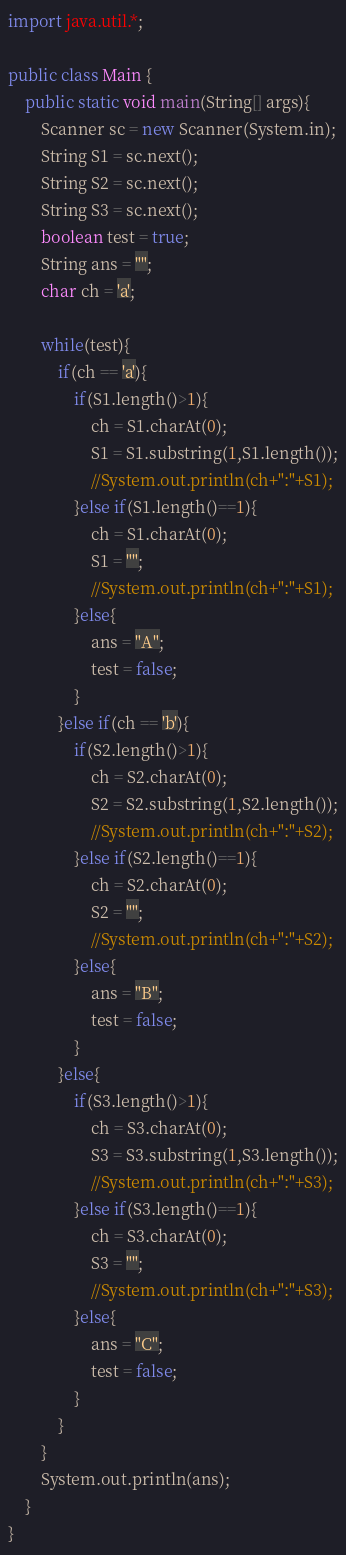<code> <loc_0><loc_0><loc_500><loc_500><_Java_>import java.util.*;

public class Main {
    public static void main(String[] args){
        Scanner sc = new Scanner(System.in);
        String S1 = sc.next();
        String S2 = sc.next();
        String S3 = sc.next();
        boolean test = true;
        String ans = "";
        char ch = 'a';
        
        while(test){
            if(ch == 'a'){
                if(S1.length()>1){
                    ch = S1.charAt(0);
                    S1 = S1.substring(1,S1.length());
                    //System.out.println(ch+":"+S1);
                }else if(S1.length()==1){
                    ch = S1.charAt(0);
                    S1 = "";
                    //System.out.println(ch+":"+S1);
                }else{
                    ans = "A";
                    test = false;
                }
            }else if(ch == 'b'){
                if(S2.length()>1){
                    ch = S2.charAt(0);
                    S2 = S2.substring(1,S2.length());
                    //System.out.println(ch+":"+S2);
                }else if(S2.length()==1){
                    ch = S2.charAt(0);
                    S2 = "";
                    //System.out.println(ch+":"+S2);
                }else{
                    ans = "B";
                    test = false;
                }
            }else{
                if(S3.length()>1){
                    ch = S3.charAt(0);
                    S3 = S3.substring(1,S3.length());
                    //System.out.println(ch+":"+S3);
                }else if(S3.length()==1){
                    ch = S3.charAt(0);
                    S3 = "";
                    //System.out.println(ch+":"+S3);
                }else{
                    ans = "C";
                    test = false;
                }
            }
        }
        System.out.println(ans);
    }
}
</code> 